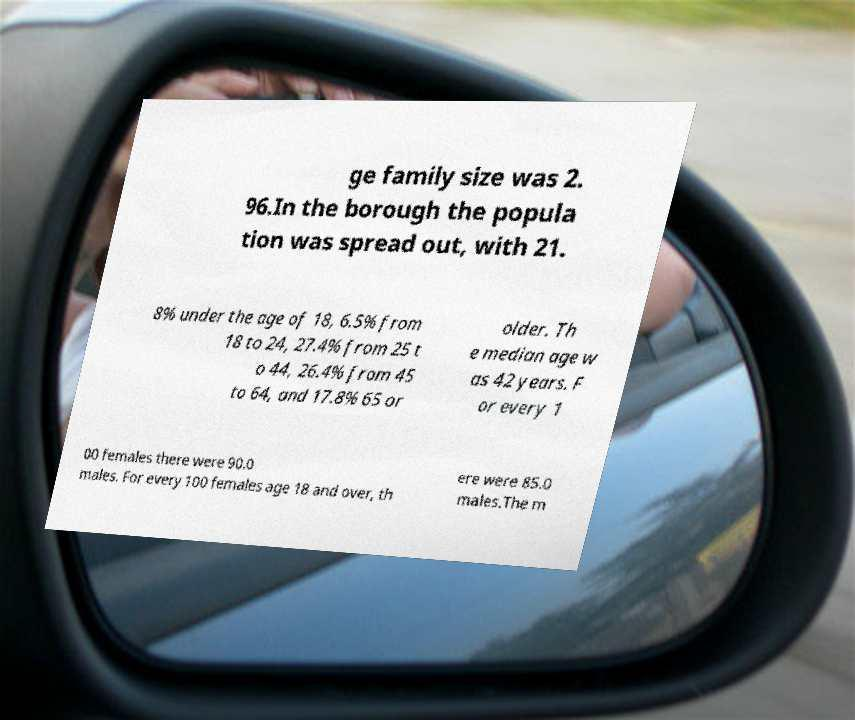What messages or text are displayed in this image? I need them in a readable, typed format. ge family size was 2. 96.In the borough the popula tion was spread out, with 21. 8% under the age of 18, 6.5% from 18 to 24, 27.4% from 25 t o 44, 26.4% from 45 to 64, and 17.8% 65 or older. Th e median age w as 42 years. F or every 1 00 females there were 90.0 males. For every 100 females age 18 and over, th ere were 85.0 males.The m 